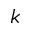Convert formula to latex. <formula><loc_0><loc_0><loc_500><loc_500>k</formula> 